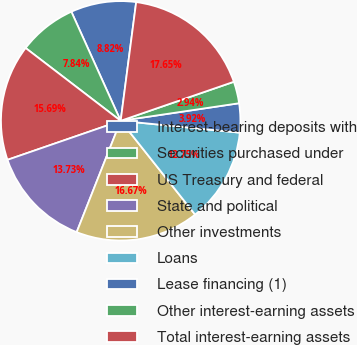<chart> <loc_0><loc_0><loc_500><loc_500><pie_chart><fcel>Interest-bearing deposits with<fcel>Securities purchased under<fcel>US Treasury and federal<fcel>State and political<fcel>Other investments<fcel>Loans<fcel>Lease financing (1)<fcel>Other interest-earning assets<fcel>Total interest-earning assets<nl><fcel>8.82%<fcel>7.84%<fcel>15.68%<fcel>13.72%<fcel>16.66%<fcel>12.74%<fcel>3.92%<fcel>2.94%<fcel>17.64%<nl></chart> 